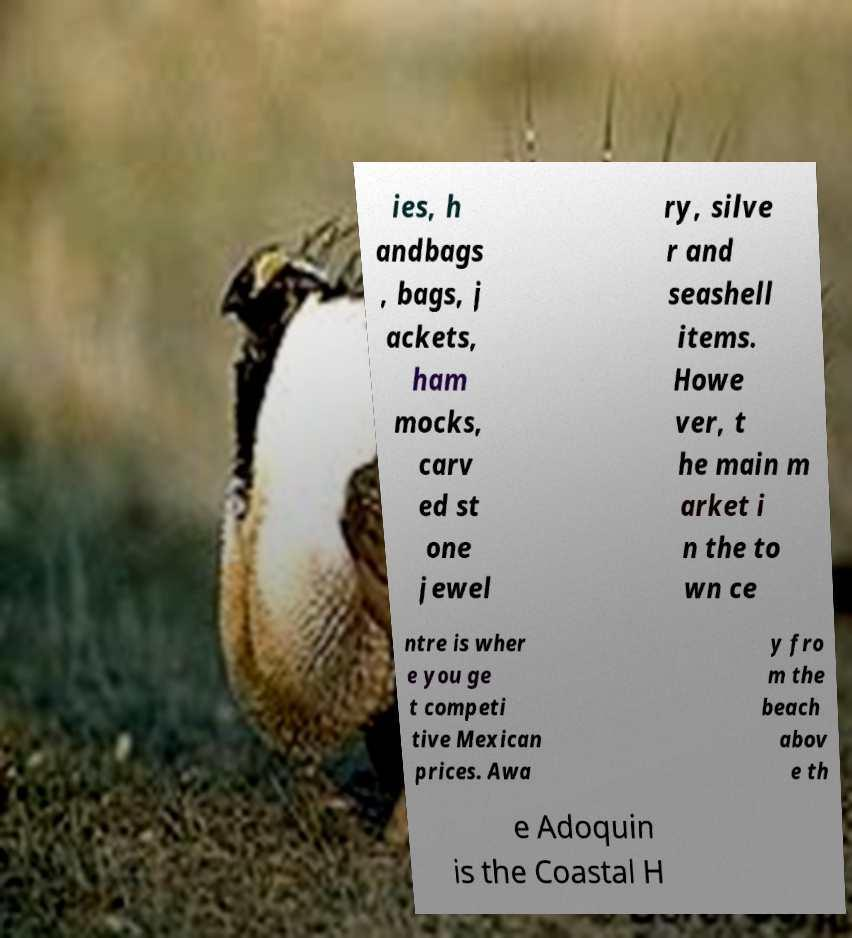What messages or text are displayed in this image? I need them in a readable, typed format. ies, h andbags , bags, j ackets, ham mocks, carv ed st one jewel ry, silve r and seashell items. Howe ver, t he main m arket i n the to wn ce ntre is wher e you ge t competi tive Mexican prices. Awa y fro m the beach abov e th e Adoquin is the Coastal H 